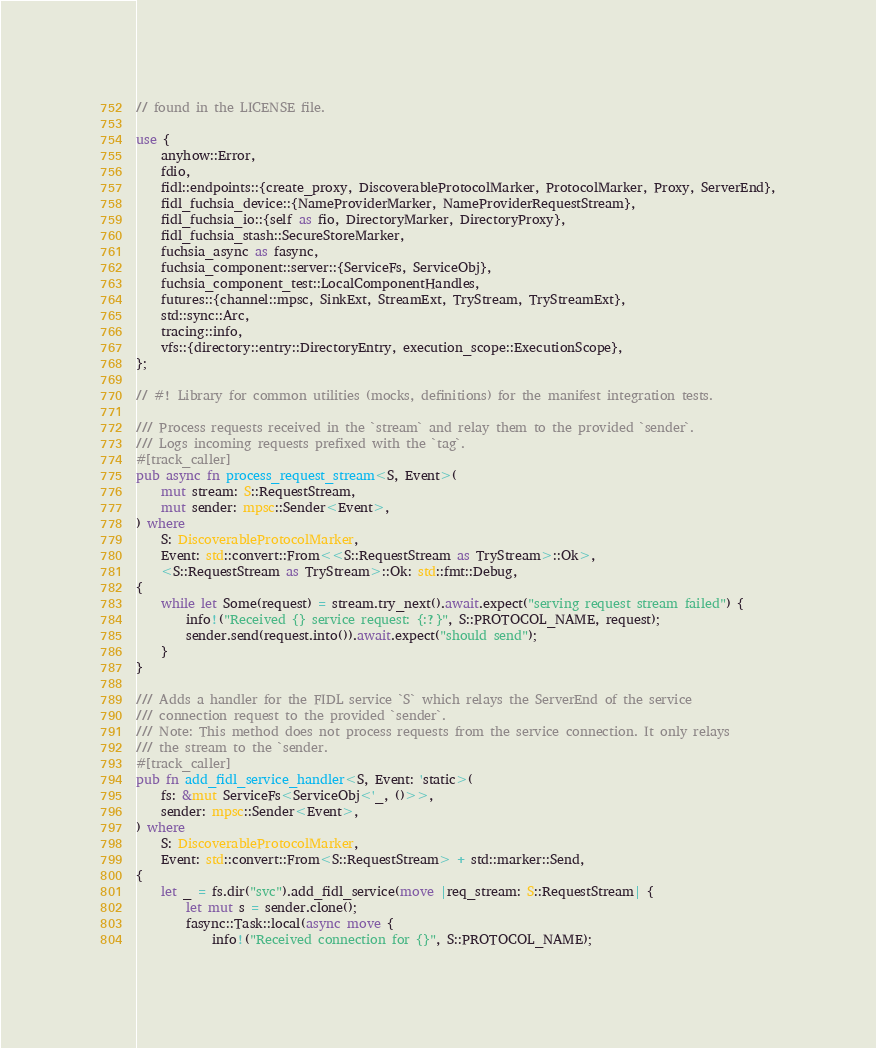Convert code to text. <code><loc_0><loc_0><loc_500><loc_500><_Rust_>// found in the LICENSE file.

use {
    anyhow::Error,
    fdio,
    fidl::endpoints::{create_proxy, DiscoverableProtocolMarker, ProtocolMarker, Proxy, ServerEnd},
    fidl_fuchsia_device::{NameProviderMarker, NameProviderRequestStream},
    fidl_fuchsia_io::{self as fio, DirectoryMarker, DirectoryProxy},
    fidl_fuchsia_stash::SecureStoreMarker,
    fuchsia_async as fasync,
    fuchsia_component::server::{ServiceFs, ServiceObj},
    fuchsia_component_test::LocalComponentHandles,
    futures::{channel::mpsc, SinkExt, StreamExt, TryStream, TryStreamExt},
    std::sync::Arc,
    tracing::info,
    vfs::{directory::entry::DirectoryEntry, execution_scope::ExecutionScope},
};

// #! Library for common utilities (mocks, definitions) for the manifest integration tests.

/// Process requests received in the `stream` and relay them to the provided `sender`.
/// Logs incoming requests prefixed with the `tag`.
#[track_caller]
pub async fn process_request_stream<S, Event>(
    mut stream: S::RequestStream,
    mut sender: mpsc::Sender<Event>,
) where
    S: DiscoverableProtocolMarker,
    Event: std::convert::From<<S::RequestStream as TryStream>::Ok>,
    <S::RequestStream as TryStream>::Ok: std::fmt::Debug,
{
    while let Some(request) = stream.try_next().await.expect("serving request stream failed") {
        info!("Received {} service request: {:?}", S::PROTOCOL_NAME, request);
        sender.send(request.into()).await.expect("should send");
    }
}

/// Adds a handler for the FIDL service `S` which relays the ServerEnd of the service
/// connection request to the provided `sender`.
/// Note: This method does not process requests from the service connection. It only relays
/// the stream to the `sender.
#[track_caller]
pub fn add_fidl_service_handler<S, Event: 'static>(
    fs: &mut ServiceFs<ServiceObj<'_, ()>>,
    sender: mpsc::Sender<Event>,
) where
    S: DiscoverableProtocolMarker,
    Event: std::convert::From<S::RequestStream> + std::marker::Send,
{
    let _ = fs.dir("svc").add_fidl_service(move |req_stream: S::RequestStream| {
        let mut s = sender.clone();
        fasync::Task::local(async move {
            info!("Received connection for {}", S::PROTOCOL_NAME);</code> 